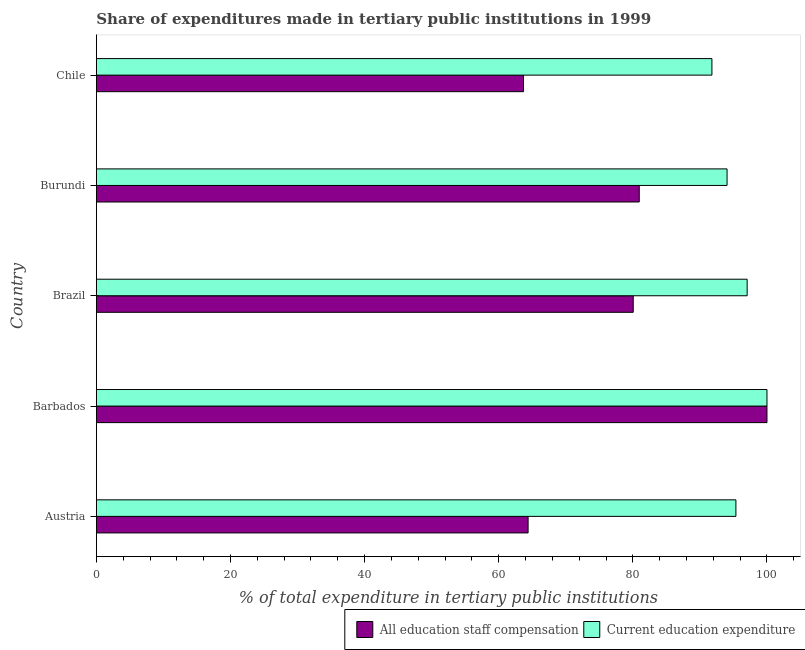How many different coloured bars are there?
Provide a succinct answer. 2. How many groups of bars are there?
Provide a short and direct response. 5. Are the number of bars on each tick of the Y-axis equal?
Ensure brevity in your answer.  Yes. How many bars are there on the 1st tick from the bottom?
Provide a succinct answer. 2. What is the expenditure in education in Chile?
Make the answer very short. 91.79. Across all countries, what is the maximum expenditure in staff compensation?
Your response must be concise. 100. Across all countries, what is the minimum expenditure in staff compensation?
Your answer should be very brief. 63.7. In which country was the expenditure in education maximum?
Your response must be concise. Barbados. In which country was the expenditure in staff compensation minimum?
Give a very brief answer. Chile. What is the total expenditure in education in the graph?
Ensure brevity in your answer.  478.26. What is the difference between the expenditure in staff compensation in Austria and that in Burundi?
Ensure brevity in your answer.  -16.57. What is the difference between the expenditure in education in Austria and the expenditure in staff compensation in Barbados?
Ensure brevity in your answer.  -4.63. What is the average expenditure in education per country?
Your answer should be compact. 95.65. What is the difference between the expenditure in education and expenditure in staff compensation in Austria?
Give a very brief answer. 30.99. In how many countries, is the expenditure in staff compensation greater than 16 %?
Give a very brief answer. 5. What is the ratio of the expenditure in staff compensation in Austria to that in Burundi?
Provide a succinct answer. 0.8. Is the difference between the expenditure in education in Brazil and Chile greater than the difference between the expenditure in staff compensation in Brazil and Chile?
Provide a succinct answer. No. What is the difference between the highest and the second highest expenditure in education?
Ensure brevity in your answer.  2.95. What is the difference between the highest and the lowest expenditure in education?
Your answer should be very brief. 8.21. What does the 1st bar from the top in Chile represents?
Offer a terse response. Current education expenditure. What does the 2nd bar from the bottom in Chile represents?
Your answer should be very brief. Current education expenditure. How many bars are there?
Your answer should be very brief. 10. What is the difference between two consecutive major ticks on the X-axis?
Offer a terse response. 20. Are the values on the major ticks of X-axis written in scientific E-notation?
Ensure brevity in your answer.  No. Where does the legend appear in the graph?
Make the answer very short. Bottom right. How many legend labels are there?
Your answer should be very brief. 2. What is the title of the graph?
Ensure brevity in your answer.  Share of expenditures made in tertiary public institutions in 1999. What is the label or title of the X-axis?
Provide a short and direct response. % of total expenditure in tertiary public institutions. What is the label or title of the Y-axis?
Your answer should be compact. Country. What is the % of total expenditure in tertiary public institutions of All education staff compensation in Austria?
Provide a succinct answer. 64.38. What is the % of total expenditure in tertiary public institutions of Current education expenditure in Austria?
Your answer should be compact. 95.37. What is the % of total expenditure in tertiary public institutions of Current education expenditure in Barbados?
Your answer should be compact. 100. What is the % of total expenditure in tertiary public institutions in All education staff compensation in Brazil?
Your response must be concise. 80.06. What is the % of total expenditure in tertiary public institutions in Current education expenditure in Brazil?
Offer a very short reply. 97.05. What is the % of total expenditure in tertiary public institutions in All education staff compensation in Burundi?
Provide a short and direct response. 80.96. What is the % of total expenditure in tertiary public institutions in Current education expenditure in Burundi?
Your response must be concise. 94.05. What is the % of total expenditure in tertiary public institutions of All education staff compensation in Chile?
Your answer should be compact. 63.7. What is the % of total expenditure in tertiary public institutions in Current education expenditure in Chile?
Give a very brief answer. 91.79. Across all countries, what is the maximum % of total expenditure in tertiary public institutions of Current education expenditure?
Give a very brief answer. 100. Across all countries, what is the minimum % of total expenditure in tertiary public institutions in All education staff compensation?
Make the answer very short. 63.7. Across all countries, what is the minimum % of total expenditure in tertiary public institutions in Current education expenditure?
Offer a terse response. 91.79. What is the total % of total expenditure in tertiary public institutions in All education staff compensation in the graph?
Your response must be concise. 389.09. What is the total % of total expenditure in tertiary public institutions in Current education expenditure in the graph?
Offer a terse response. 478.26. What is the difference between the % of total expenditure in tertiary public institutions of All education staff compensation in Austria and that in Barbados?
Keep it short and to the point. -35.62. What is the difference between the % of total expenditure in tertiary public institutions of Current education expenditure in Austria and that in Barbados?
Offer a very short reply. -4.63. What is the difference between the % of total expenditure in tertiary public institutions in All education staff compensation in Austria and that in Brazil?
Ensure brevity in your answer.  -15.68. What is the difference between the % of total expenditure in tertiary public institutions in Current education expenditure in Austria and that in Brazil?
Provide a short and direct response. -1.68. What is the difference between the % of total expenditure in tertiary public institutions in All education staff compensation in Austria and that in Burundi?
Your answer should be compact. -16.57. What is the difference between the % of total expenditure in tertiary public institutions in Current education expenditure in Austria and that in Burundi?
Your answer should be very brief. 1.32. What is the difference between the % of total expenditure in tertiary public institutions in All education staff compensation in Austria and that in Chile?
Ensure brevity in your answer.  0.69. What is the difference between the % of total expenditure in tertiary public institutions of Current education expenditure in Austria and that in Chile?
Ensure brevity in your answer.  3.57. What is the difference between the % of total expenditure in tertiary public institutions of All education staff compensation in Barbados and that in Brazil?
Your response must be concise. 19.94. What is the difference between the % of total expenditure in tertiary public institutions of Current education expenditure in Barbados and that in Brazil?
Your answer should be very brief. 2.95. What is the difference between the % of total expenditure in tertiary public institutions of All education staff compensation in Barbados and that in Burundi?
Offer a terse response. 19.04. What is the difference between the % of total expenditure in tertiary public institutions in Current education expenditure in Barbados and that in Burundi?
Ensure brevity in your answer.  5.95. What is the difference between the % of total expenditure in tertiary public institutions of All education staff compensation in Barbados and that in Chile?
Ensure brevity in your answer.  36.3. What is the difference between the % of total expenditure in tertiary public institutions in Current education expenditure in Barbados and that in Chile?
Your response must be concise. 8.21. What is the difference between the % of total expenditure in tertiary public institutions of All education staff compensation in Brazil and that in Burundi?
Offer a very short reply. -0.9. What is the difference between the % of total expenditure in tertiary public institutions in Current education expenditure in Brazil and that in Burundi?
Your response must be concise. 3. What is the difference between the % of total expenditure in tertiary public institutions in All education staff compensation in Brazil and that in Chile?
Make the answer very short. 16.36. What is the difference between the % of total expenditure in tertiary public institutions of Current education expenditure in Brazil and that in Chile?
Make the answer very short. 5.25. What is the difference between the % of total expenditure in tertiary public institutions in All education staff compensation in Burundi and that in Chile?
Ensure brevity in your answer.  17.26. What is the difference between the % of total expenditure in tertiary public institutions of Current education expenditure in Burundi and that in Chile?
Give a very brief answer. 2.26. What is the difference between the % of total expenditure in tertiary public institutions in All education staff compensation in Austria and the % of total expenditure in tertiary public institutions in Current education expenditure in Barbados?
Your response must be concise. -35.62. What is the difference between the % of total expenditure in tertiary public institutions in All education staff compensation in Austria and the % of total expenditure in tertiary public institutions in Current education expenditure in Brazil?
Offer a terse response. -32.67. What is the difference between the % of total expenditure in tertiary public institutions in All education staff compensation in Austria and the % of total expenditure in tertiary public institutions in Current education expenditure in Burundi?
Provide a short and direct response. -29.67. What is the difference between the % of total expenditure in tertiary public institutions of All education staff compensation in Austria and the % of total expenditure in tertiary public institutions of Current education expenditure in Chile?
Ensure brevity in your answer.  -27.41. What is the difference between the % of total expenditure in tertiary public institutions in All education staff compensation in Barbados and the % of total expenditure in tertiary public institutions in Current education expenditure in Brazil?
Your answer should be compact. 2.95. What is the difference between the % of total expenditure in tertiary public institutions in All education staff compensation in Barbados and the % of total expenditure in tertiary public institutions in Current education expenditure in Burundi?
Offer a very short reply. 5.95. What is the difference between the % of total expenditure in tertiary public institutions of All education staff compensation in Barbados and the % of total expenditure in tertiary public institutions of Current education expenditure in Chile?
Your response must be concise. 8.21. What is the difference between the % of total expenditure in tertiary public institutions in All education staff compensation in Brazil and the % of total expenditure in tertiary public institutions in Current education expenditure in Burundi?
Keep it short and to the point. -13.99. What is the difference between the % of total expenditure in tertiary public institutions in All education staff compensation in Brazil and the % of total expenditure in tertiary public institutions in Current education expenditure in Chile?
Keep it short and to the point. -11.73. What is the difference between the % of total expenditure in tertiary public institutions of All education staff compensation in Burundi and the % of total expenditure in tertiary public institutions of Current education expenditure in Chile?
Keep it short and to the point. -10.84. What is the average % of total expenditure in tertiary public institutions in All education staff compensation per country?
Make the answer very short. 77.82. What is the average % of total expenditure in tertiary public institutions in Current education expenditure per country?
Your response must be concise. 95.65. What is the difference between the % of total expenditure in tertiary public institutions of All education staff compensation and % of total expenditure in tertiary public institutions of Current education expenditure in Austria?
Ensure brevity in your answer.  -30.99. What is the difference between the % of total expenditure in tertiary public institutions of All education staff compensation and % of total expenditure in tertiary public institutions of Current education expenditure in Barbados?
Keep it short and to the point. 0. What is the difference between the % of total expenditure in tertiary public institutions in All education staff compensation and % of total expenditure in tertiary public institutions in Current education expenditure in Brazil?
Offer a terse response. -16.99. What is the difference between the % of total expenditure in tertiary public institutions in All education staff compensation and % of total expenditure in tertiary public institutions in Current education expenditure in Burundi?
Give a very brief answer. -13.1. What is the difference between the % of total expenditure in tertiary public institutions in All education staff compensation and % of total expenditure in tertiary public institutions in Current education expenditure in Chile?
Provide a succinct answer. -28.1. What is the ratio of the % of total expenditure in tertiary public institutions of All education staff compensation in Austria to that in Barbados?
Make the answer very short. 0.64. What is the ratio of the % of total expenditure in tertiary public institutions in Current education expenditure in Austria to that in Barbados?
Provide a succinct answer. 0.95. What is the ratio of the % of total expenditure in tertiary public institutions in All education staff compensation in Austria to that in Brazil?
Keep it short and to the point. 0.8. What is the ratio of the % of total expenditure in tertiary public institutions of Current education expenditure in Austria to that in Brazil?
Offer a very short reply. 0.98. What is the ratio of the % of total expenditure in tertiary public institutions of All education staff compensation in Austria to that in Burundi?
Your answer should be compact. 0.8. What is the ratio of the % of total expenditure in tertiary public institutions of All education staff compensation in Austria to that in Chile?
Keep it short and to the point. 1.01. What is the ratio of the % of total expenditure in tertiary public institutions of Current education expenditure in Austria to that in Chile?
Offer a very short reply. 1.04. What is the ratio of the % of total expenditure in tertiary public institutions in All education staff compensation in Barbados to that in Brazil?
Your response must be concise. 1.25. What is the ratio of the % of total expenditure in tertiary public institutions in Current education expenditure in Barbados to that in Brazil?
Offer a very short reply. 1.03. What is the ratio of the % of total expenditure in tertiary public institutions in All education staff compensation in Barbados to that in Burundi?
Ensure brevity in your answer.  1.24. What is the ratio of the % of total expenditure in tertiary public institutions of Current education expenditure in Barbados to that in Burundi?
Ensure brevity in your answer.  1.06. What is the ratio of the % of total expenditure in tertiary public institutions in All education staff compensation in Barbados to that in Chile?
Make the answer very short. 1.57. What is the ratio of the % of total expenditure in tertiary public institutions of Current education expenditure in Barbados to that in Chile?
Your answer should be very brief. 1.09. What is the ratio of the % of total expenditure in tertiary public institutions in All education staff compensation in Brazil to that in Burundi?
Make the answer very short. 0.99. What is the ratio of the % of total expenditure in tertiary public institutions of Current education expenditure in Brazil to that in Burundi?
Your answer should be very brief. 1.03. What is the ratio of the % of total expenditure in tertiary public institutions in All education staff compensation in Brazil to that in Chile?
Provide a short and direct response. 1.26. What is the ratio of the % of total expenditure in tertiary public institutions in Current education expenditure in Brazil to that in Chile?
Your answer should be compact. 1.06. What is the ratio of the % of total expenditure in tertiary public institutions of All education staff compensation in Burundi to that in Chile?
Provide a short and direct response. 1.27. What is the ratio of the % of total expenditure in tertiary public institutions of Current education expenditure in Burundi to that in Chile?
Keep it short and to the point. 1.02. What is the difference between the highest and the second highest % of total expenditure in tertiary public institutions of All education staff compensation?
Make the answer very short. 19.04. What is the difference between the highest and the second highest % of total expenditure in tertiary public institutions in Current education expenditure?
Provide a short and direct response. 2.95. What is the difference between the highest and the lowest % of total expenditure in tertiary public institutions of All education staff compensation?
Offer a very short reply. 36.3. What is the difference between the highest and the lowest % of total expenditure in tertiary public institutions of Current education expenditure?
Give a very brief answer. 8.21. 